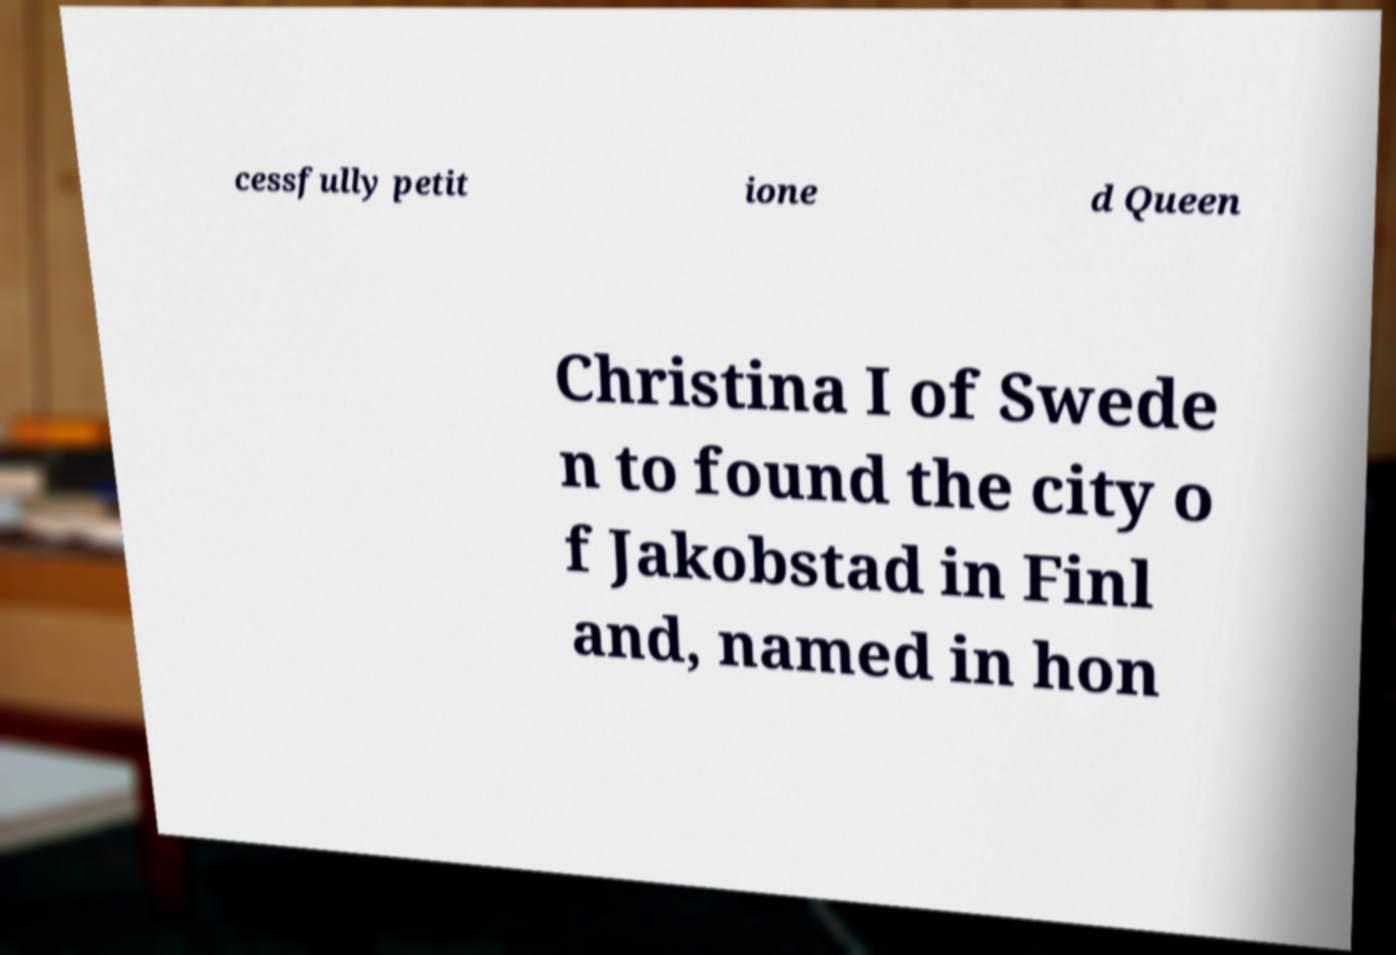For documentation purposes, I need the text within this image transcribed. Could you provide that? cessfully petit ione d Queen Christina I of Swede n to found the city o f Jakobstad in Finl and, named in hon 